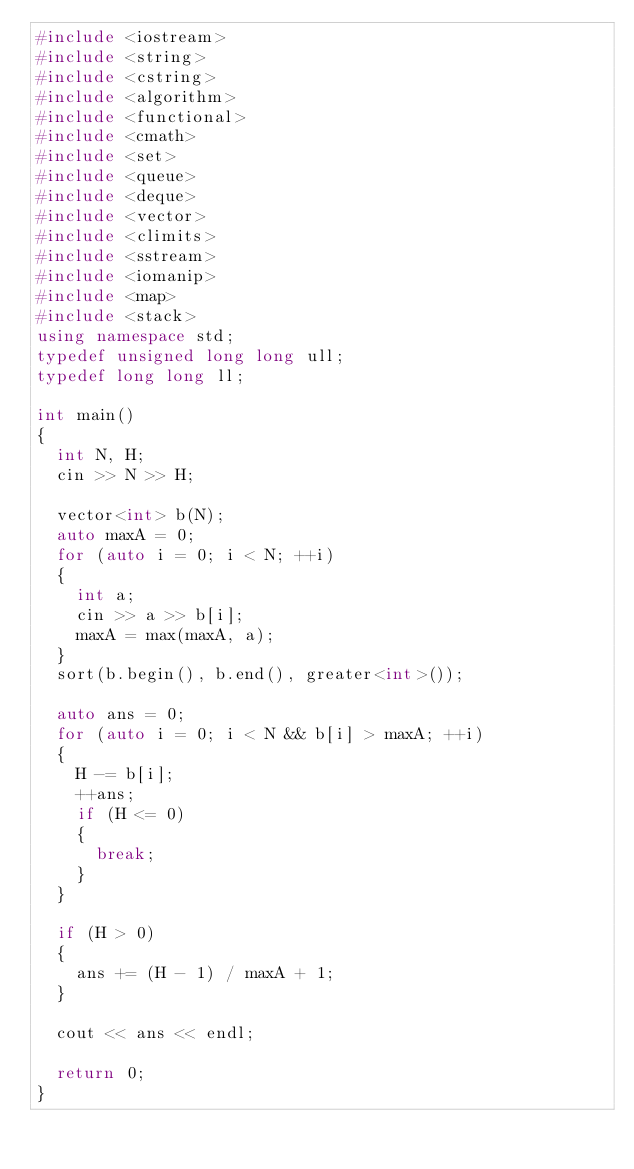<code> <loc_0><loc_0><loc_500><loc_500><_C++_>#include <iostream>
#include <string>
#include <cstring>
#include <algorithm>
#include <functional>
#include <cmath>
#include <set>
#include <queue>
#include <deque>
#include <vector>
#include <climits>
#include <sstream>
#include <iomanip>
#include <map>
#include <stack>
using namespace std;
typedef unsigned long long ull;
typedef long long ll;

int main()
{
	int N, H;
	cin >> N >> H;

	vector<int> b(N);
	auto maxA = 0;
	for (auto i = 0; i < N; ++i)
	{
		int a;
		cin >> a >> b[i];
		maxA = max(maxA, a);
	}
	sort(b.begin(), b.end(), greater<int>());

	auto ans = 0;
	for (auto i = 0; i < N && b[i] > maxA; ++i)
	{
		H -= b[i];
		++ans;
		if (H <= 0)
		{
			break;
		}
	}

	if (H > 0)
	{
		ans += (H - 1) / maxA + 1;
	}

	cout << ans << endl;

	return 0;
}</code> 